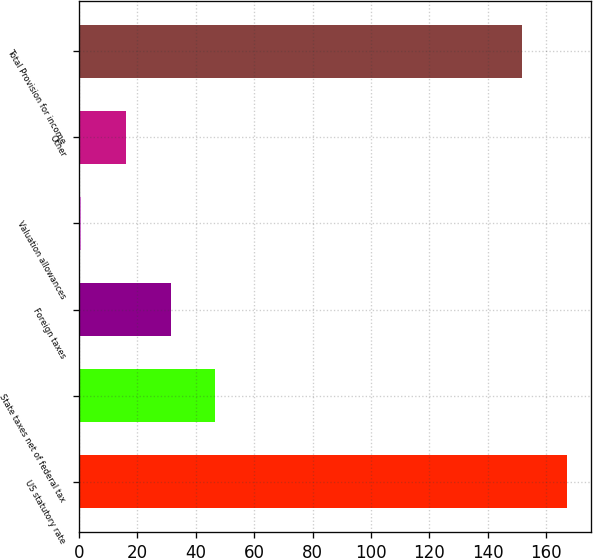<chart> <loc_0><loc_0><loc_500><loc_500><bar_chart><fcel>US statutory rate<fcel>State taxes net of federal tax<fcel>Foreign taxes<fcel>Valuation allowances<fcel>Other<fcel>Total Provision for income<nl><fcel>167.07<fcel>46.71<fcel>31.44<fcel>0.9<fcel>16.17<fcel>151.8<nl></chart> 